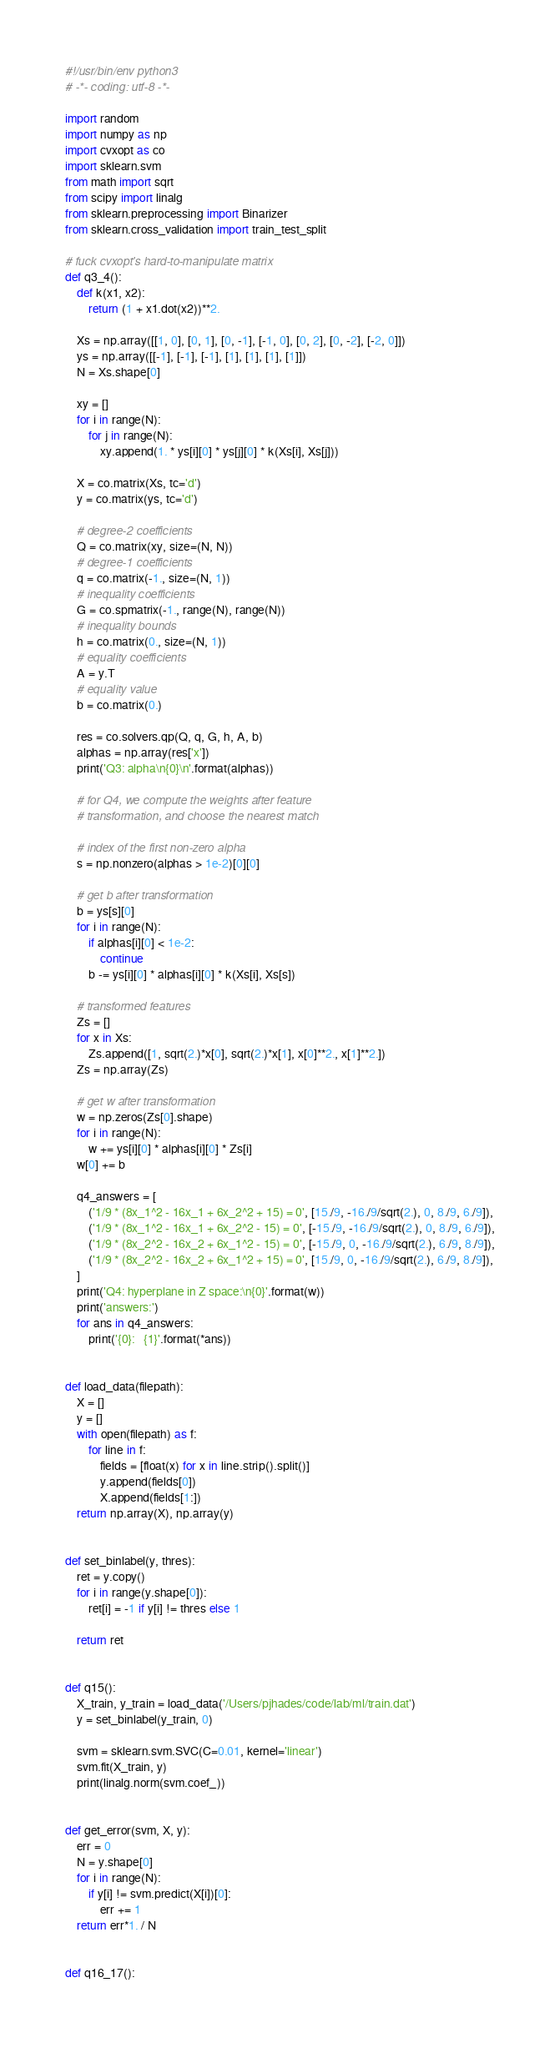<code> <loc_0><loc_0><loc_500><loc_500><_Python_>#!/usr/bin/env python3
# -*- coding: utf-8 -*-

import random
import numpy as np
import cvxopt as co
import sklearn.svm
from math import sqrt
from scipy import linalg
from sklearn.preprocessing import Binarizer
from sklearn.cross_validation import train_test_split

# fuck cvxopt's hard-to-manipulate matrix
def q3_4():
    def k(x1, x2):
        return (1 + x1.dot(x2))**2.

    Xs = np.array([[1, 0], [0, 1], [0, -1], [-1, 0], [0, 2], [0, -2], [-2, 0]])
    ys = np.array([[-1], [-1], [-1], [1], [1], [1], [1]])
    N = Xs.shape[0]

    xy = []
    for i in range(N):
        for j in range(N):
            xy.append(1. * ys[i][0] * ys[j][0] * k(Xs[i], Xs[j]))

    X = co.matrix(Xs, tc='d')
    y = co.matrix(ys, tc='d')

    # degree-2 coefficients
    Q = co.matrix(xy, size=(N, N))
    # degree-1 coefficients
    q = co.matrix(-1., size=(N, 1))
    # inequality coefficients
    G = co.spmatrix(-1., range(N), range(N))
    # inequality bounds
    h = co.matrix(0., size=(N, 1))
    # equality coefficients
    A = y.T
    # equality value
    b = co.matrix(0.)

    res = co.solvers.qp(Q, q, G, h, A, b)
    alphas = np.array(res['x'])
    print('Q3: alpha\n{0}\n'.format(alphas))

    # for Q4, we compute the weights after feature
    # transformation, and choose the nearest match

    # index of the first non-zero alpha
    s = np.nonzero(alphas > 1e-2)[0][0]

    # get b after transformation
    b = ys[s][0]
    for i in range(N):
        if alphas[i][0] < 1e-2:
            continue
        b -= ys[i][0] * alphas[i][0] * k(Xs[i], Xs[s])

    # transformed features
    Zs = []
    for x in Xs:
        Zs.append([1, sqrt(2.)*x[0], sqrt(2.)*x[1], x[0]**2., x[1]**2.])
    Zs = np.array(Zs)

    # get w after transformation
    w = np.zeros(Zs[0].shape)
    for i in range(N):
        w += ys[i][0] * alphas[i][0] * Zs[i]
    w[0] += b

    q4_answers = [
        ('1/9 * (8x_1^2 - 16x_1 + 6x_2^2 + 15) = 0', [15./9, -16./9/sqrt(2.), 0, 8./9, 6./9]),
        ('1/9 * (8x_1^2 - 16x_1 + 6x_2^2 - 15) = 0', [-15./9, -16./9/sqrt(2.), 0, 8./9, 6./9]),
        ('1/9 * (8x_2^2 - 16x_2 + 6x_1^2 - 15) = 0', [-15./9, 0, -16./9/sqrt(2.), 6./9, 8./9]),
        ('1/9 * (8x_2^2 - 16x_2 + 6x_1^2 + 15) = 0', [15./9, 0, -16./9/sqrt(2.), 6./9, 8./9]),
    ]
    print('Q4: hyperplane in Z space:\n{0}'.format(w))
    print('answers:')
    for ans in q4_answers:
        print('{0}:   {1}'.format(*ans))


def load_data(filepath):
    X = []
    y = []
    with open(filepath) as f:
        for line in f:
            fields = [float(x) for x in line.strip().split()]
            y.append(fields[0])
            X.append(fields[1:])
    return np.array(X), np.array(y)


def set_binlabel(y, thres):
    ret = y.copy()
    for i in range(y.shape[0]):
        ret[i] = -1 if y[i] != thres else 1

    return ret


def q15():
    X_train, y_train = load_data('/Users/pjhades/code/lab/ml/train.dat')
    y = set_binlabel(y_train, 0)

    svm = sklearn.svm.SVC(C=0.01, kernel='linear') 
    svm.fit(X_train, y)
    print(linalg.norm(svm.coef_))


def get_error(svm, X, y):
    err = 0
    N = y.shape[0]
    for i in range(N):
        if y[i] != svm.predict(X[i])[0]:
            err += 1
    return err*1. / N


def q16_17():</code> 